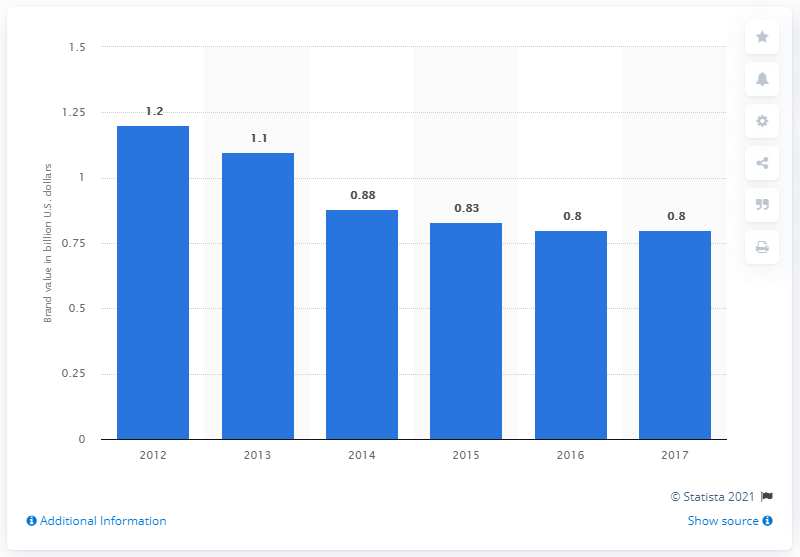List a handful of essential elements in this visual. In 2017, the brand value of Reebok was approximately 0.8 billion dollars. 